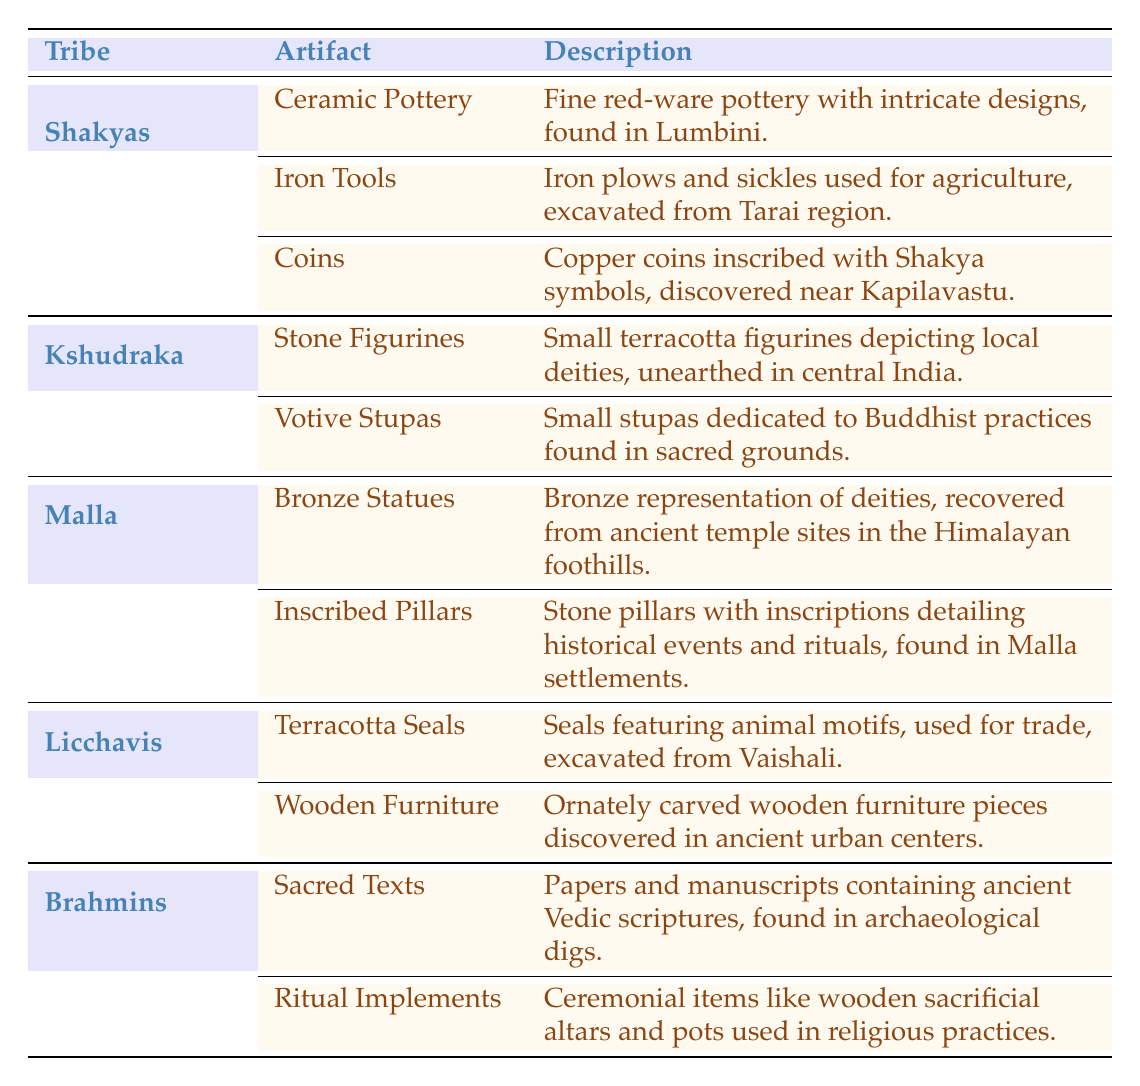What artifacts are associated with the Shakyas tribe? The Shakyas tribe is associated with three artifacts listed in the table: Ceramic Pottery, Iron Tools, and Coins. The descriptions can be directly found by referring to their respective rows under the Shakyas section.
Answer: Ceramic Pottery, Iron Tools, Coins What type of artifacts were found for the Licchavis tribe? The Licchavis tribe has two artifacts mentioned: Terracotta Seals and Wooden Furniture. By looking under the Licchavis row, we find these artifacts listed with their descriptions.
Answer: Terracotta Seals, Wooden Furniture Did the Malla tribe have any inscriptions as artifacts? Yes, the Malla tribe is noted for having Inscribed Pillars as one of their artifacts. Checking the Malla row confirms this fact, making the answer true.
Answer: Yes How many artifacts are listed under the Brahmins tribe? There are two artifacts listed under the Brahmins tribe: Sacred Texts and Ritual Implements. This is determined by counting the rows associated with the Brahmins entry in the table.
Answer: 2 Are Iron Tools mentioned as artifacts for the Kshudraka tribe? No, Iron Tools are not mentioned for the Kshudraka tribe. A review of the Kshudraka section reveals that the artifacts listed are Stone Figurines and Votive Stupas, confirming that Iron Tools are not included.
Answer: No What is the total number of artifacts associated with the Shakyas and Malla tribes combined? The Shakyas tribe has three artifacts and the Malla tribe has two artifacts. Adding these together gives a total of 3 + 2 = 5 artifacts for the combined tribes.
Answer: 5 Which tribe is associated with the artifacts depicting local deities? The artifacts depicting local deities are Stone Figurines, which are associated with the Kshudraka tribe. Upon examining the table, we find this information within the Kshudraka section.
Answer: Kshudraka What is the description of the Copper coins found near Kapilavastu? The Copper coins are described as being inscribed with Shakya symbols, with the specific finding location being near Kapilavastu. This information can be directly referred to in the Shakyas section of the table.
Answer: Copper coins inscribed with Shakya symbols, found near Kapilavastu 